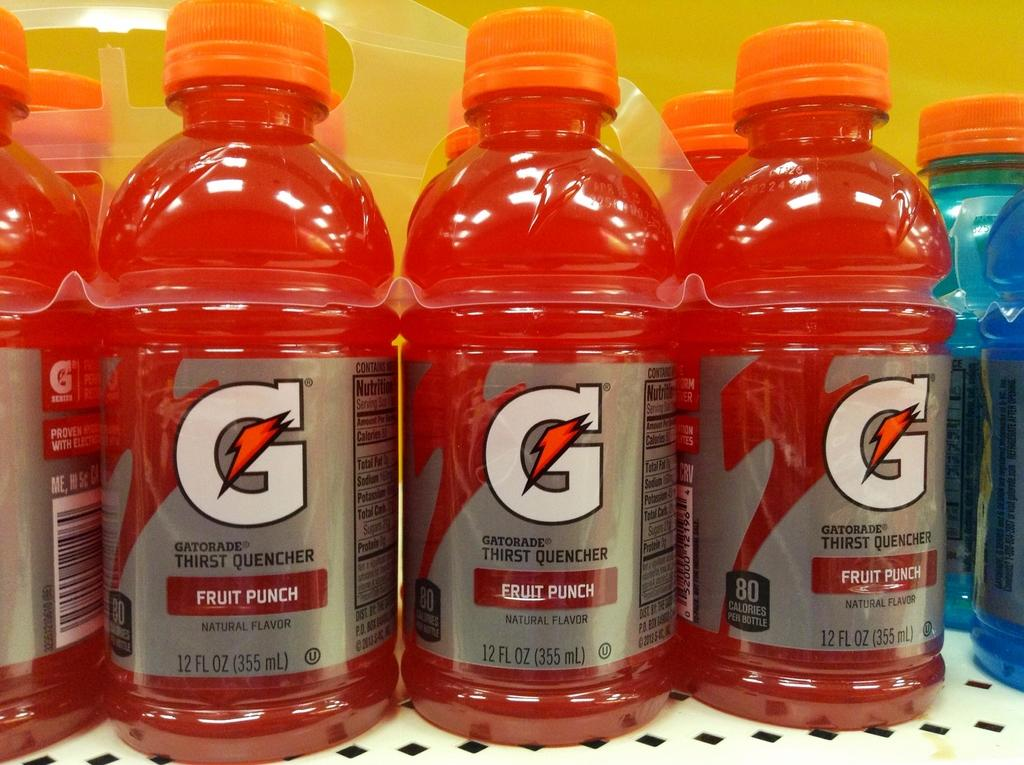<image>
Share a concise interpretation of the image provided. Several bottles of Gatorade fruit punch are on display. 